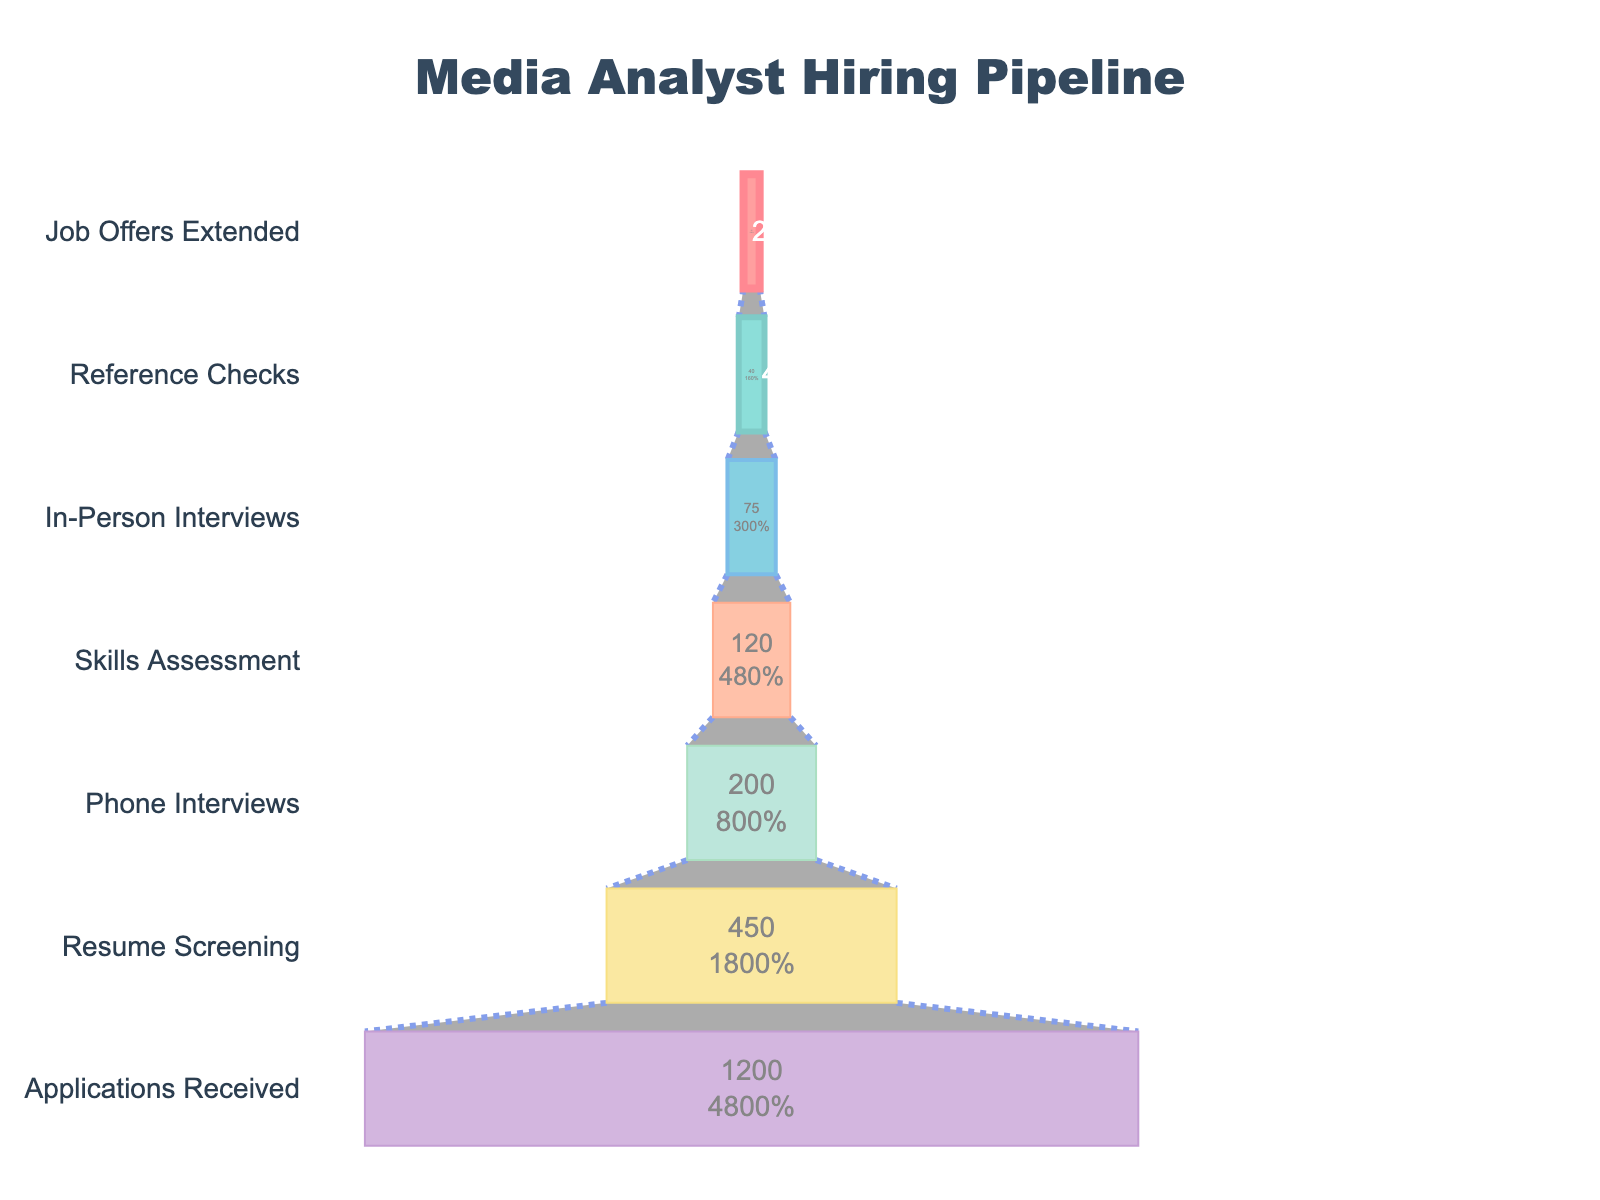What's the title of the figure? The title is displayed at the top center of the figure.
Answer: Media Analyst Hiring Pipeline What is the total number of candidates who received applications? The first stage of the funnel chart shows the number of applications received as 1200.
Answer: 1200 How many stages are included in the hiring pipeline? The funnel chart lists each stage vertically. Counting them reveals there are seven stages.
Answer: 7 Which stage has the highest drop-off in candidate numbers? By looking at the differences between successive stages, the drop-off from Applications Received (1200) to Resume Screening (450) is the largest.
Answer: Resume Screening What percentage of candidates passed the Phone Interviews stage? The Phone Interviews stage has 200 candidates. This is calculated as (200/1200)*100%.
Answer: 16.67% What is the difference in candidate numbers between the Skills Assessment and the In-Person Interviews stages? Subtract the number of candidates in In-Person Interviews (75) from Skills Assessment (120).
Answer: 45 Compare the number of candidates between Resume Screening and In-Person Interviews. Which stage has more candidates and by how much? Resume Screening has 450 candidates, and In-Person Interviews has 75. Resume Screening has 450 - 75 = 375 more candidates.
Answer: Resume Screening by 375 What is the total number of candidates from the final three stages combined? Sum of candidates in In-Person Interviews (75), Reference Checks (40), and Job Offers Extended (25) is 75 + 40 + 25.
Answer: 140 Which stage represents the midway point in the funnel regarding the number of stages? With 7 stages in total, the midway point is the 4th stage, Skills Assessment.
Answer: Skills Assessment 